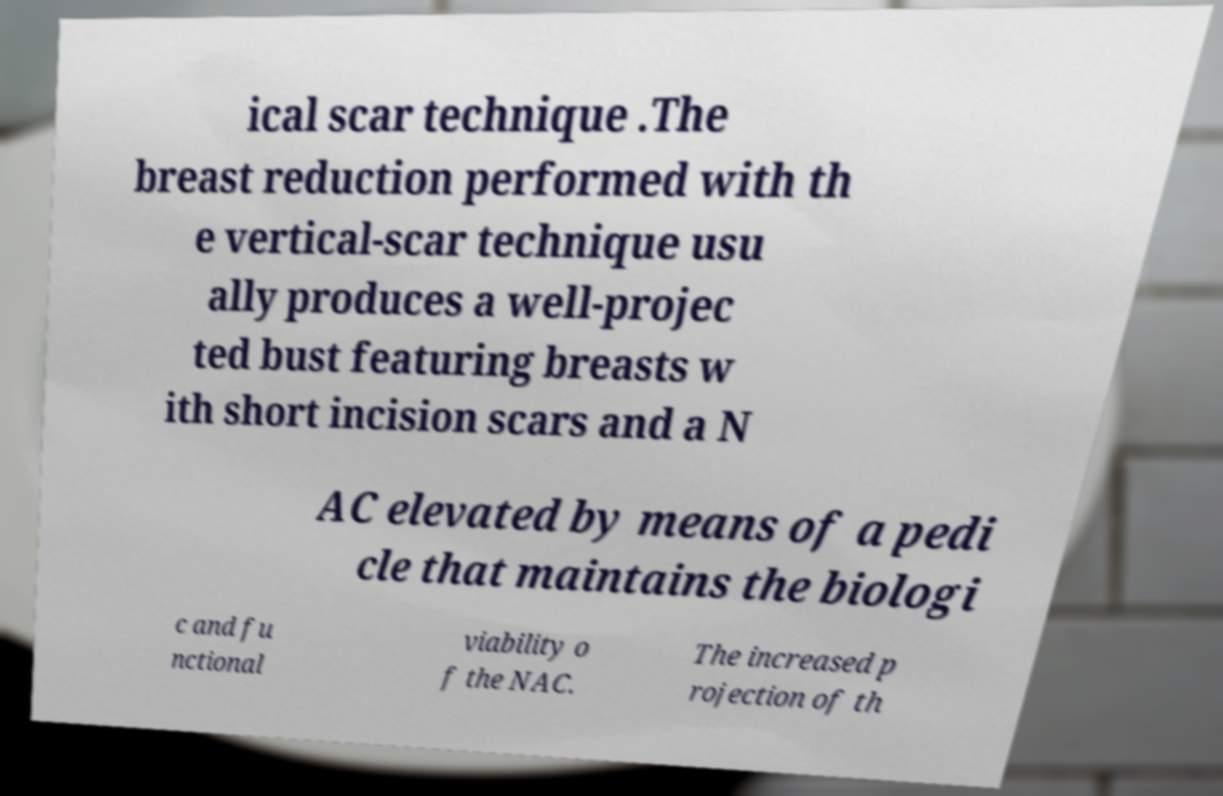Can you read and provide the text displayed in the image?This photo seems to have some interesting text. Can you extract and type it out for me? ical scar technique .The breast reduction performed with th e vertical-scar technique usu ally produces a well-projec ted bust featuring breasts w ith short incision scars and a N AC elevated by means of a pedi cle that maintains the biologi c and fu nctional viability o f the NAC. The increased p rojection of th 